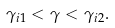<formula> <loc_0><loc_0><loc_500><loc_500>\gamma _ { i 1 } < \gamma < \gamma _ { i 2 } .</formula> 